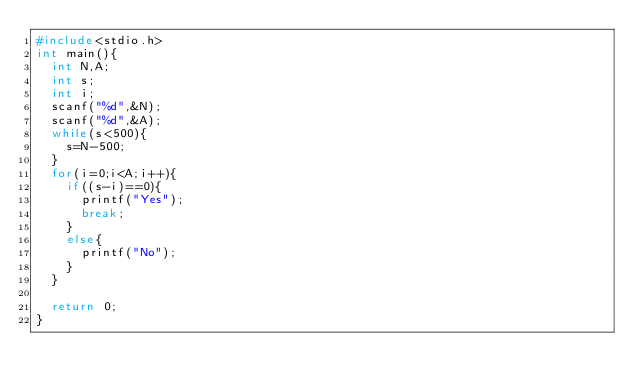<code> <loc_0><loc_0><loc_500><loc_500><_C_>#include<stdio.h>
int main(){
  int N,A;
  int s;
  int i;
  scanf("%d",&N);
  scanf("%d",&A);
  while(s<500){
    s=N-500;
  }
  for(i=0;i<A;i++){
    if((s-i)==0){
      printf("Yes");
      break;
    }
    else{
      printf("No");
    }
  }

  return 0;
}
</code> 